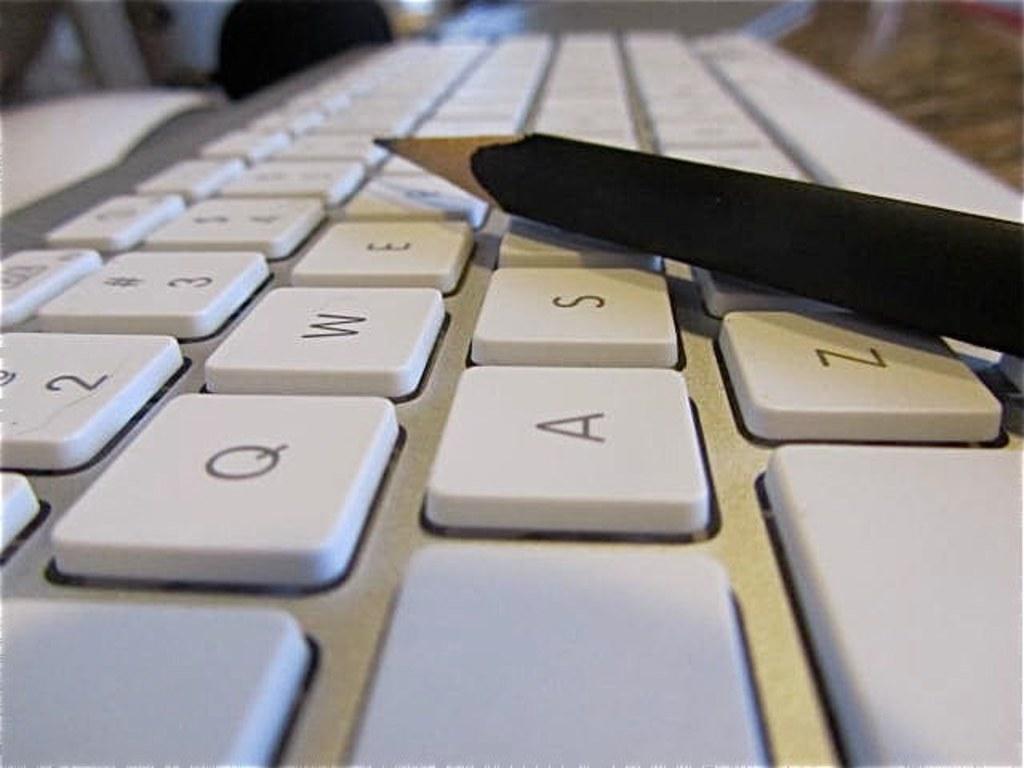What is the key next to the a?
Your answer should be compact. S. What key is to the right of q?
Make the answer very short. W. 